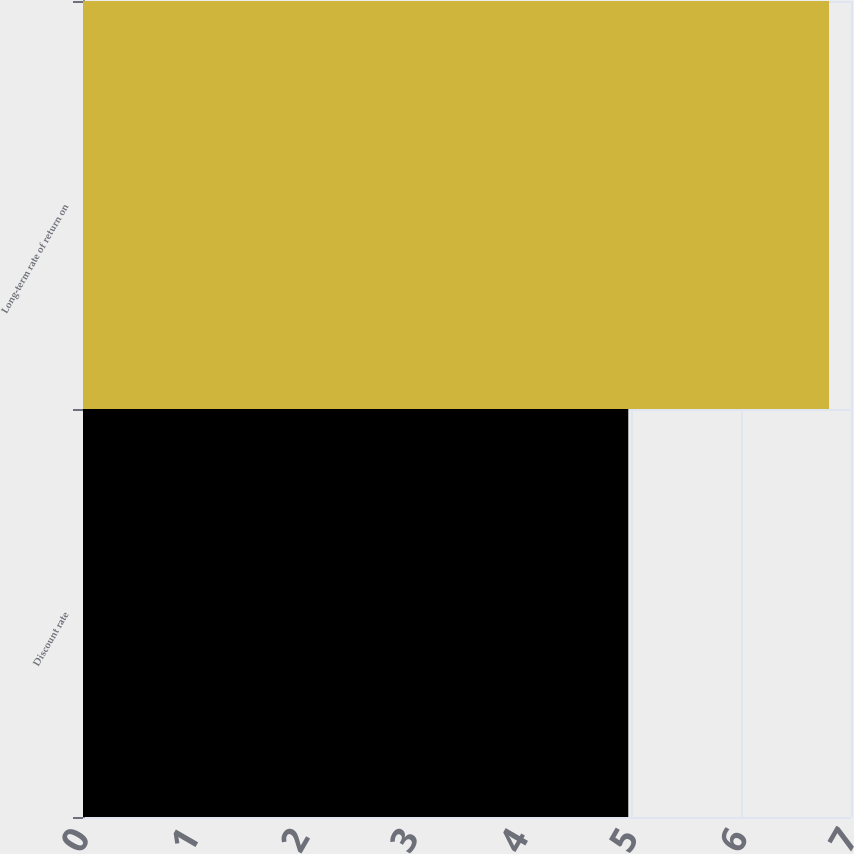Convert chart. <chart><loc_0><loc_0><loc_500><loc_500><bar_chart><fcel>Discount rate<fcel>Long-term rate of return on<nl><fcel>4.97<fcel>6.8<nl></chart> 